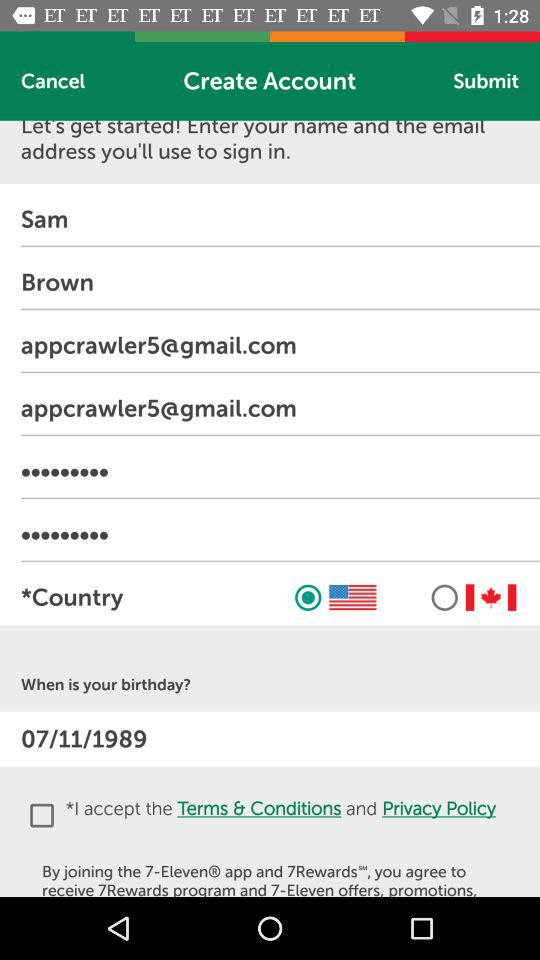What is the name of the user? The name of the user is Sam Brown. 